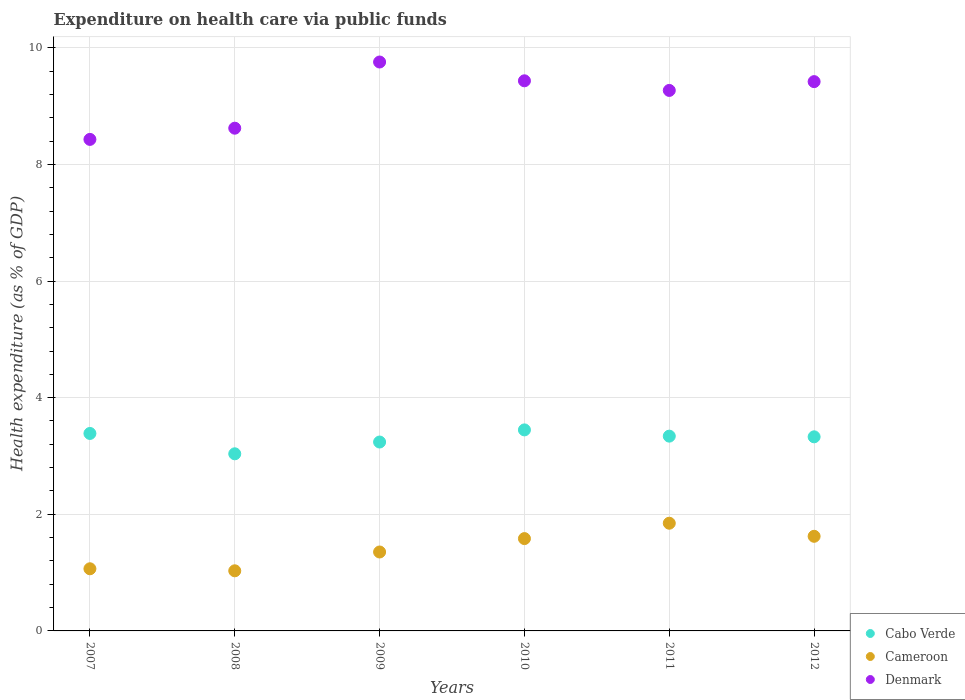Is the number of dotlines equal to the number of legend labels?
Offer a terse response. Yes. What is the expenditure made on health care in Cameroon in 2008?
Give a very brief answer. 1.03. Across all years, what is the maximum expenditure made on health care in Denmark?
Offer a terse response. 9.76. Across all years, what is the minimum expenditure made on health care in Denmark?
Your answer should be compact. 8.43. In which year was the expenditure made on health care in Denmark minimum?
Provide a succinct answer. 2007. What is the total expenditure made on health care in Cameroon in the graph?
Your answer should be very brief. 8.5. What is the difference between the expenditure made on health care in Cabo Verde in 2007 and that in 2009?
Provide a short and direct response. 0.15. What is the difference between the expenditure made on health care in Denmark in 2012 and the expenditure made on health care in Cabo Verde in 2009?
Ensure brevity in your answer.  6.18. What is the average expenditure made on health care in Denmark per year?
Keep it short and to the point. 9.15. In the year 2010, what is the difference between the expenditure made on health care in Cabo Verde and expenditure made on health care in Cameroon?
Offer a very short reply. 1.86. What is the ratio of the expenditure made on health care in Cameroon in 2008 to that in 2011?
Ensure brevity in your answer.  0.56. Is the expenditure made on health care in Cabo Verde in 2010 less than that in 2011?
Offer a terse response. No. Is the difference between the expenditure made on health care in Cabo Verde in 2007 and 2010 greater than the difference between the expenditure made on health care in Cameroon in 2007 and 2010?
Provide a short and direct response. Yes. What is the difference between the highest and the second highest expenditure made on health care in Cabo Verde?
Give a very brief answer. 0.06. What is the difference between the highest and the lowest expenditure made on health care in Denmark?
Keep it short and to the point. 1.33. In how many years, is the expenditure made on health care in Denmark greater than the average expenditure made on health care in Denmark taken over all years?
Give a very brief answer. 4. Does the expenditure made on health care in Cameroon monotonically increase over the years?
Give a very brief answer. No. Is the expenditure made on health care in Denmark strictly greater than the expenditure made on health care in Cameroon over the years?
Ensure brevity in your answer.  Yes. Is the expenditure made on health care in Cabo Verde strictly less than the expenditure made on health care in Denmark over the years?
Offer a very short reply. Yes. What is the difference between two consecutive major ticks on the Y-axis?
Your answer should be very brief. 2. Does the graph contain grids?
Make the answer very short. Yes. What is the title of the graph?
Give a very brief answer. Expenditure on health care via public funds. What is the label or title of the Y-axis?
Keep it short and to the point. Health expenditure (as % of GDP). What is the Health expenditure (as % of GDP) of Cabo Verde in 2007?
Provide a short and direct response. 3.39. What is the Health expenditure (as % of GDP) of Cameroon in 2007?
Give a very brief answer. 1.07. What is the Health expenditure (as % of GDP) in Denmark in 2007?
Ensure brevity in your answer.  8.43. What is the Health expenditure (as % of GDP) in Cabo Verde in 2008?
Your response must be concise. 3.04. What is the Health expenditure (as % of GDP) in Cameroon in 2008?
Your answer should be compact. 1.03. What is the Health expenditure (as % of GDP) in Denmark in 2008?
Offer a terse response. 8.62. What is the Health expenditure (as % of GDP) in Cabo Verde in 2009?
Provide a short and direct response. 3.24. What is the Health expenditure (as % of GDP) in Cameroon in 2009?
Your answer should be compact. 1.35. What is the Health expenditure (as % of GDP) of Denmark in 2009?
Offer a very short reply. 9.76. What is the Health expenditure (as % of GDP) of Cabo Verde in 2010?
Provide a short and direct response. 3.45. What is the Health expenditure (as % of GDP) of Cameroon in 2010?
Give a very brief answer. 1.58. What is the Health expenditure (as % of GDP) of Denmark in 2010?
Offer a very short reply. 9.43. What is the Health expenditure (as % of GDP) of Cabo Verde in 2011?
Keep it short and to the point. 3.34. What is the Health expenditure (as % of GDP) in Cameroon in 2011?
Provide a short and direct response. 1.85. What is the Health expenditure (as % of GDP) of Denmark in 2011?
Your answer should be compact. 9.27. What is the Health expenditure (as % of GDP) in Cabo Verde in 2012?
Keep it short and to the point. 3.33. What is the Health expenditure (as % of GDP) of Cameroon in 2012?
Offer a very short reply. 1.62. What is the Health expenditure (as % of GDP) of Denmark in 2012?
Keep it short and to the point. 9.42. Across all years, what is the maximum Health expenditure (as % of GDP) in Cabo Verde?
Your answer should be compact. 3.45. Across all years, what is the maximum Health expenditure (as % of GDP) of Cameroon?
Offer a terse response. 1.85. Across all years, what is the maximum Health expenditure (as % of GDP) of Denmark?
Ensure brevity in your answer.  9.76. Across all years, what is the minimum Health expenditure (as % of GDP) of Cabo Verde?
Ensure brevity in your answer.  3.04. Across all years, what is the minimum Health expenditure (as % of GDP) in Cameroon?
Your answer should be compact. 1.03. Across all years, what is the minimum Health expenditure (as % of GDP) of Denmark?
Offer a very short reply. 8.43. What is the total Health expenditure (as % of GDP) of Cabo Verde in the graph?
Provide a short and direct response. 19.78. What is the total Health expenditure (as % of GDP) of Cameroon in the graph?
Keep it short and to the point. 8.5. What is the total Health expenditure (as % of GDP) of Denmark in the graph?
Offer a terse response. 54.93. What is the difference between the Health expenditure (as % of GDP) of Cabo Verde in 2007 and that in 2008?
Your answer should be compact. 0.35. What is the difference between the Health expenditure (as % of GDP) in Cameroon in 2007 and that in 2008?
Your answer should be compact. 0.03. What is the difference between the Health expenditure (as % of GDP) in Denmark in 2007 and that in 2008?
Make the answer very short. -0.19. What is the difference between the Health expenditure (as % of GDP) in Cabo Verde in 2007 and that in 2009?
Give a very brief answer. 0.15. What is the difference between the Health expenditure (as % of GDP) of Cameroon in 2007 and that in 2009?
Keep it short and to the point. -0.29. What is the difference between the Health expenditure (as % of GDP) of Denmark in 2007 and that in 2009?
Offer a terse response. -1.33. What is the difference between the Health expenditure (as % of GDP) of Cabo Verde in 2007 and that in 2010?
Give a very brief answer. -0.06. What is the difference between the Health expenditure (as % of GDP) of Cameroon in 2007 and that in 2010?
Provide a short and direct response. -0.52. What is the difference between the Health expenditure (as % of GDP) in Denmark in 2007 and that in 2010?
Provide a short and direct response. -1. What is the difference between the Health expenditure (as % of GDP) in Cabo Verde in 2007 and that in 2011?
Offer a very short reply. 0.05. What is the difference between the Health expenditure (as % of GDP) of Cameroon in 2007 and that in 2011?
Offer a very short reply. -0.78. What is the difference between the Health expenditure (as % of GDP) in Denmark in 2007 and that in 2011?
Offer a terse response. -0.84. What is the difference between the Health expenditure (as % of GDP) of Cabo Verde in 2007 and that in 2012?
Your answer should be compact. 0.06. What is the difference between the Health expenditure (as % of GDP) in Cameroon in 2007 and that in 2012?
Offer a very short reply. -0.56. What is the difference between the Health expenditure (as % of GDP) of Denmark in 2007 and that in 2012?
Your answer should be compact. -0.99. What is the difference between the Health expenditure (as % of GDP) in Cabo Verde in 2008 and that in 2009?
Your response must be concise. -0.2. What is the difference between the Health expenditure (as % of GDP) in Cameroon in 2008 and that in 2009?
Your answer should be very brief. -0.32. What is the difference between the Health expenditure (as % of GDP) of Denmark in 2008 and that in 2009?
Provide a succinct answer. -1.13. What is the difference between the Health expenditure (as % of GDP) of Cabo Verde in 2008 and that in 2010?
Your answer should be compact. -0.41. What is the difference between the Health expenditure (as % of GDP) in Cameroon in 2008 and that in 2010?
Your response must be concise. -0.55. What is the difference between the Health expenditure (as % of GDP) of Denmark in 2008 and that in 2010?
Give a very brief answer. -0.81. What is the difference between the Health expenditure (as % of GDP) in Cabo Verde in 2008 and that in 2011?
Ensure brevity in your answer.  -0.3. What is the difference between the Health expenditure (as % of GDP) in Cameroon in 2008 and that in 2011?
Make the answer very short. -0.82. What is the difference between the Health expenditure (as % of GDP) in Denmark in 2008 and that in 2011?
Keep it short and to the point. -0.65. What is the difference between the Health expenditure (as % of GDP) in Cabo Verde in 2008 and that in 2012?
Keep it short and to the point. -0.29. What is the difference between the Health expenditure (as % of GDP) of Cameroon in 2008 and that in 2012?
Provide a short and direct response. -0.59. What is the difference between the Health expenditure (as % of GDP) of Denmark in 2008 and that in 2012?
Your response must be concise. -0.8. What is the difference between the Health expenditure (as % of GDP) of Cabo Verde in 2009 and that in 2010?
Offer a terse response. -0.21. What is the difference between the Health expenditure (as % of GDP) of Cameroon in 2009 and that in 2010?
Make the answer very short. -0.23. What is the difference between the Health expenditure (as % of GDP) in Denmark in 2009 and that in 2010?
Make the answer very short. 0.32. What is the difference between the Health expenditure (as % of GDP) of Cabo Verde in 2009 and that in 2011?
Keep it short and to the point. -0.1. What is the difference between the Health expenditure (as % of GDP) of Cameroon in 2009 and that in 2011?
Ensure brevity in your answer.  -0.49. What is the difference between the Health expenditure (as % of GDP) of Denmark in 2009 and that in 2011?
Offer a very short reply. 0.49. What is the difference between the Health expenditure (as % of GDP) in Cabo Verde in 2009 and that in 2012?
Make the answer very short. -0.09. What is the difference between the Health expenditure (as % of GDP) in Cameroon in 2009 and that in 2012?
Your answer should be very brief. -0.27. What is the difference between the Health expenditure (as % of GDP) in Denmark in 2009 and that in 2012?
Provide a succinct answer. 0.34. What is the difference between the Health expenditure (as % of GDP) of Cabo Verde in 2010 and that in 2011?
Provide a succinct answer. 0.11. What is the difference between the Health expenditure (as % of GDP) of Cameroon in 2010 and that in 2011?
Provide a succinct answer. -0.26. What is the difference between the Health expenditure (as % of GDP) in Denmark in 2010 and that in 2011?
Give a very brief answer. 0.17. What is the difference between the Health expenditure (as % of GDP) in Cabo Verde in 2010 and that in 2012?
Ensure brevity in your answer.  0.12. What is the difference between the Health expenditure (as % of GDP) of Cameroon in 2010 and that in 2012?
Your response must be concise. -0.04. What is the difference between the Health expenditure (as % of GDP) in Denmark in 2010 and that in 2012?
Give a very brief answer. 0.01. What is the difference between the Health expenditure (as % of GDP) of Cabo Verde in 2011 and that in 2012?
Offer a very short reply. 0.01. What is the difference between the Health expenditure (as % of GDP) in Cameroon in 2011 and that in 2012?
Provide a succinct answer. 0.22. What is the difference between the Health expenditure (as % of GDP) in Denmark in 2011 and that in 2012?
Your response must be concise. -0.15. What is the difference between the Health expenditure (as % of GDP) in Cabo Verde in 2007 and the Health expenditure (as % of GDP) in Cameroon in 2008?
Make the answer very short. 2.36. What is the difference between the Health expenditure (as % of GDP) of Cabo Verde in 2007 and the Health expenditure (as % of GDP) of Denmark in 2008?
Provide a short and direct response. -5.23. What is the difference between the Health expenditure (as % of GDP) of Cameroon in 2007 and the Health expenditure (as % of GDP) of Denmark in 2008?
Ensure brevity in your answer.  -7.56. What is the difference between the Health expenditure (as % of GDP) in Cabo Verde in 2007 and the Health expenditure (as % of GDP) in Cameroon in 2009?
Your answer should be compact. 2.03. What is the difference between the Health expenditure (as % of GDP) of Cabo Verde in 2007 and the Health expenditure (as % of GDP) of Denmark in 2009?
Your answer should be very brief. -6.37. What is the difference between the Health expenditure (as % of GDP) in Cameroon in 2007 and the Health expenditure (as % of GDP) in Denmark in 2009?
Your response must be concise. -8.69. What is the difference between the Health expenditure (as % of GDP) of Cabo Verde in 2007 and the Health expenditure (as % of GDP) of Cameroon in 2010?
Keep it short and to the point. 1.8. What is the difference between the Health expenditure (as % of GDP) of Cabo Verde in 2007 and the Health expenditure (as % of GDP) of Denmark in 2010?
Keep it short and to the point. -6.05. What is the difference between the Health expenditure (as % of GDP) of Cameroon in 2007 and the Health expenditure (as % of GDP) of Denmark in 2010?
Offer a very short reply. -8.37. What is the difference between the Health expenditure (as % of GDP) in Cabo Verde in 2007 and the Health expenditure (as % of GDP) in Cameroon in 2011?
Ensure brevity in your answer.  1.54. What is the difference between the Health expenditure (as % of GDP) in Cabo Verde in 2007 and the Health expenditure (as % of GDP) in Denmark in 2011?
Offer a very short reply. -5.88. What is the difference between the Health expenditure (as % of GDP) of Cameroon in 2007 and the Health expenditure (as % of GDP) of Denmark in 2011?
Offer a very short reply. -8.2. What is the difference between the Health expenditure (as % of GDP) of Cabo Verde in 2007 and the Health expenditure (as % of GDP) of Cameroon in 2012?
Keep it short and to the point. 1.76. What is the difference between the Health expenditure (as % of GDP) of Cabo Verde in 2007 and the Health expenditure (as % of GDP) of Denmark in 2012?
Offer a terse response. -6.03. What is the difference between the Health expenditure (as % of GDP) in Cameroon in 2007 and the Health expenditure (as % of GDP) in Denmark in 2012?
Provide a short and direct response. -8.35. What is the difference between the Health expenditure (as % of GDP) in Cabo Verde in 2008 and the Health expenditure (as % of GDP) in Cameroon in 2009?
Offer a terse response. 1.68. What is the difference between the Health expenditure (as % of GDP) in Cabo Verde in 2008 and the Health expenditure (as % of GDP) in Denmark in 2009?
Give a very brief answer. -6.72. What is the difference between the Health expenditure (as % of GDP) in Cameroon in 2008 and the Health expenditure (as % of GDP) in Denmark in 2009?
Your answer should be very brief. -8.73. What is the difference between the Health expenditure (as % of GDP) of Cabo Verde in 2008 and the Health expenditure (as % of GDP) of Cameroon in 2010?
Give a very brief answer. 1.45. What is the difference between the Health expenditure (as % of GDP) of Cabo Verde in 2008 and the Health expenditure (as % of GDP) of Denmark in 2010?
Provide a short and direct response. -6.4. What is the difference between the Health expenditure (as % of GDP) in Cameroon in 2008 and the Health expenditure (as % of GDP) in Denmark in 2010?
Your answer should be very brief. -8.4. What is the difference between the Health expenditure (as % of GDP) of Cabo Verde in 2008 and the Health expenditure (as % of GDP) of Cameroon in 2011?
Provide a succinct answer. 1.19. What is the difference between the Health expenditure (as % of GDP) of Cabo Verde in 2008 and the Health expenditure (as % of GDP) of Denmark in 2011?
Make the answer very short. -6.23. What is the difference between the Health expenditure (as % of GDP) of Cameroon in 2008 and the Health expenditure (as % of GDP) of Denmark in 2011?
Give a very brief answer. -8.24. What is the difference between the Health expenditure (as % of GDP) of Cabo Verde in 2008 and the Health expenditure (as % of GDP) of Cameroon in 2012?
Provide a short and direct response. 1.41. What is the difference between the Health expenditure (as % of GDP) in Cabo Verde in 2008 and the Health expenditure (as % of GDP) in Denmark in 2012?
Provide a short and direct response. -6.38. What is the difference between the Health expenditure (as % of GDP) of Cameroon in 2008 and the Health expenditure (as % of GDP) of Denmark in 2012?
Your response must be concise. -8.39. What is the difference between the Health expenditure (as % of GDP) in Cabo Verde in 2009 and the Health expenditure (as % of GDP) in Cameroon in 2010?
Provide a succinct answer. 1.66. What is the difference between the Health expenditure (as % of GDP) of Cabo Verde in 2009 and the Health expenditure (as % of GDP) of Denmark in 2010?
Provide a succinct answer. -6.19. What is the difference between the Health expenditure (as % of GDP) of Cameroon in 2009 and the Health expenditure (as % of GDP) of Denmark in 2010?
Offer a terse response. -8.08. What is the difference between the Health expenditure (as % of GDP) in Cabo Verde in 2009 and the Health expenditure (as % of GDP) in Cameroon in 2011?
Provide a succinct answer. 1.39. What is the difference between the Health expenditure (as % of GDP) in Cabo Verde in 2009 and the Health expenditure (as % of GDP) in Denmark in 2011?
Keep it short and to the point. -6.03. What is the difference between the Health expenditure (as % of GDP) in Cameroon in 2009 and the Health expenditure (as % of GDP) in Denmark in 2011?
Ensure brevity in your answer.  -7.92. What is the difference between the Health expenditure (as % of GDP) of Cabo Verde in 2009 and the Health expenditure (as % of GDP) of Cameroon in 2012?
Make the answer very short. 1.62. What is the difference between the Health expenditure (as % of GDP) of Cabo Verde in 2009 and the Health expenditure (as % of GDP) of Denmark in 2012?
Your answer should be compact. -6.18. What is the difference between the Health expenditure (as % of GDP) in Cameroon in 2009 and the Health expenditure (as % of GDP) in Denmark in 2012?
Keep it short and to the point. -8.07. What is the difference between the Health expenditure (as % of GDP) of Cabo Verde in 2010 and the Health expenditure (as % of GDP) of Cameroon in 2011?
Offer a very short reply. 1.6. What is the difference between the Health expenditure (as % of GDP) in Cabo Verde in 2010 and the Health expenditure (as % of GDP) in Denmark in 2011?
Give a very brief answer. -5.82. What is the difference between the Health expenditure (as % of GDP) of Cameroon in 2010 and the Health expenditure (as % of GDP) of Denmark in 2011?
Keep it short and to the point. -7.69. What is the difference between the Health expenditure (as % of GDP) in Cabo Verde in 2010 and the Health expenditure (as % of GDP) in Cameroon in 2012?
Your response must be concise. 1.82. What is the difference between the Health expenditure (as % of GDP) in Cabo Verde in 2010 and the Health expenditure (as % of GDP) in Denmark in 2012?
Your response must be concise. -5.97. What is the difference between the Health expenditure (as % of GDP) in Cameroon in 2010 and the Health expenditure (as % of GDP) in Denmark in 2012?
Ensure brevity in your answer.  -7.84. What is the difference between the Health expenditure (as % of GDP) of Cabo Verde in 2011 and the Health expenditure (as % of GDP) of Cameroon in 2012?
Offer a terse response. 1.72. What is the difference between the Health expenditure (as % of GDP) of Cabo Verde in 2011 and the Health expenditure (as % of GDP) of Denmark in 2012?
Your answer should be very brief. -6.08. What is the difference between the Health expenditure (as % of GDP) in Cameroon in 2011 and the Health expenditure (as % of GDP) in Denmark in 2012?
Ensure brevity in your answer.  -7.57. What is the average Health expenditure (as % of GDP) in Cabo Verde per year?
Make the answer very short. 3.3. What is the average Health expenditure (as % of GDP) of Cameroon per year?
Keep it short and to the point. 1.42. What is the average Health expenditure (as % of GDP) in Denmark per year?
Offer a terse response. 9.15. In the year 2007, what is the difference between the Health expenditure (as % of GDP) of Cabo Verde and Health expenditure (as % of GDP) of Cameroon?
Provide a succinct answer. 2.32. In the year 2007, what is the difference between the Health expenditure (as % of GDP) in Cabo Verde and Health expenditure (as % of GDP) in Denmark?
Keep it short and to the point. -5.04. In the year 2007, what is the difference between the Health expenditure (as % of GDP) in Cameroon and Health expenditure (as % of GDP) in Denmark?
Your answer should be compact. -7.36. In the year 2008, what is the difference between the Health expenditure (as % of GDP) of Cabo Verde and Health expenditure (as % of GDP) of Cameroon?
Provide a succinct answer. 2.01. In the year 2008, what is the difference between the Health expenditure (as % of GDP) in Cabo Verde and Health expenditure (as % of GDP) in Denmark?
Your answer should be very brief. -5.58. In the year 2008, what is the difference between the Health expenditure (as % of GDP) in Cameroon and Health expenditure (as % of GDP) in Denmark?
Provide a short and direct response. -7.59. In the year 2009, what is the difference between the Health expenditure (as % of GDP) in Cabo Verde and Health expenditure (as % of GDP) in Cameroon?
Provide a succinct answer. 1.89. In the year 2009, what is the difference between the Health expenditure (as % of GDP) of Cabo Verde and Health expenditure (as % of GDP) of Denmark?
Your response must be concise. -6.52. In the year 2009, what is the difference between the Health expenditure (as % of GDP) in Cameroon and Health expenditure (as % of GDP) in Denmark?
Your answer should be very brief. -8.4. In the year 2010, what is the difference between the Health expenditure (as % of GDP) in Cabo Verde and Health expenditure (as % of GDP) in Cameroon?
Offer a terse response. 1.86. In the year 2010, what is the difference between the Health expenditure (as % of GDP) of Cabo Verde and Health expenditure (as % of GDP) of Denmark?
Ensure brevity in your answer.  -5.99. In the year 2010, what is the difference between the Health expenditure (as % of GDP) in Cameroon and Health expenditure (as % of GDP) in Denmark?
Provide a short and direct response. -7.85. In the year 2011, what is the difference between the Health expenditure (as % of GDP) of Cabo Verde and Health expenditure (as % of GDP) of Cameroon?
Your response must be concise. 1.49. In the year 2011, what is the difference between the Health expenditure (as % of GDP) in Cabo Verde and Health expenditure (as % of GDP) in Denmark?
Offer a terse response. -5.93. In the year 2011, what is the difference between the Health expenditure (as % of GDP) in Cameroon and Health expenditure (as % of GDP) in Denmark?
Make the answer very short. -7.42. In the year 2012, what is the difference between the Health expenditure (as % of GDP) of Cabo Verde and Health expenditure (as % of GDP) of Cameroon?
Ensure brevity in your answer.  1.71. In the year 2012, what is the difference between the Health expenditure (as % of GDP) of Cabo Verde and Health expenditure (as % of GDP) of Denmark?
Offer a very short reply. -6.09. In the year 2012, what is the difference between the Health expenditure (as % of GDP) in Cameroon and Health expenditure (as % of GDP) in Denmark?
Keep it short and to the point. -7.8. What is the ratio of the Health expenditure (as % of GDP) in Cabo Verde in 2007 to that in 2008?
Provide a short and direct response. 1.11. What is the ratio of the Health expenditure (as % of GDP) in Cameroon in 2007 to that in 2008?
Your answer should be compact. 1.03. What is the ratio of the Health expenditure (as % of GDP) in Denmark in 2007 to that in 2008?
Provide a succinct answer. 0.98. What is the ratio of the Health expenditure (as % of GDP) in Cabo Verde in 2007 to that in 2009?
Your answer should be very brief. 1.05. What is the ratio of the Health expenditure (as % of GDP) in Cameroon in 2007 to that in 2009?
Provide a succinct answer. 0.79. What is the ratio of the Health expenditure (as % of GDP) of Denmark in 2007 to that in 2009?
Your response must be concise. 0.86. What is the ratio of the Health expenditure (as % of GDP) of Cabo Verde in 2007 to that in 2010?
Ensure brevity in your answer.  0.98. What is the ratio of the Health expenditure (as % of GDP) in Cameroon in 2007 to that in 2010?
Provide a succinct answer. 0.67. What is the ratio of the Health expenditure (as % of GDP) of Denmark in 2007 to that in 2010?
Give a very brief answer. 0.89. What is the ratio of the Health expenditure (as % of GDP) of Cabo Verde in 2007 to that in 2011?
Offer a terse response. 1.01. What is the ratio of the Health expenditure (as % of GDP) of Cameroon in 2007 to that in 2011?
Give a very brief answer. 0.58. What is the ratio of the Health expenditure (as % of GDP) of Denmark in 2007 to that in 2011?
Ensure brevity in your answer.  0.91. What is the ratio of the Health expenditure (as % of GDP) of Cabo Verde in 2007 to that in 2012?
Your answer should be compact. 1.02. What is the ratio of the Health expenditure (as % of GDP) in Cameroon in 2007 to that in 2012?
Your answer should be compact. 0.66. What is the ratio of the Health expenditure (as % of GDP) of Denmark in 2007 to that in 2012?
Offer a terse response. 0.89. What is the ratio of the Health expenditure (as % of GDP) of Cabo Verde in 2008 to that in 2009?
Offer a terse response. 0.94. What is the ratio of the Health expenditure (as % of GDP) in Cameroon in 2008 to that in 2009?
Offer a terse response. 0.76. What is the ratio of the Health expenditure (as % of GDP) of Denmark in 2008 to that in 2009?
Ensure brevity in your answer.  0.88. What is the ratio of the Health expenditure (as % of GDP) in Cabo Verde in 2008 to that in 2010?
Give a very brief answer. 0.88. What is the ratio of the Health expenditure (as % of GDP) in Cameroon in 2008 to that in 2010?
Offer a very short reply. 0.65. What is the ratio of the Health expenditure (as % of GDP) of Denmark in 2008 to that in 2010?
Offer a very short reply. 0.91. What is the ratio of the Health expenditure (as % of GDP) in Cabo Verde in 2008 to that in 2011?
Give a very brief answer. 0.91. What is the ratio of the Health expenditure (as % of GDP) in Cameroon in 2008 to that in 2011?
Offer a very short reply. 0.56. What is the ratio of the Health expenditure (as % of GDP) of Denmark in 2008 to that in 2011?
Keep it short and to the point. 0.93. What is the ratio of the Health expenditure (as % of GDP) in Cabo Verde in 2008 to that in 2012?
Keep it short and to the point. 0.91. What is the ratio of the Health expenditure (as % of GDP) in Cameroon in 2008 to that in 2012?
Provide a succinct answer. 0.64. What is the ratio of the Health expenditure (as % of GDP) of Denmark in 2008 to that in 2012?
Provide a succinct answer. 0.92. What is the ratio of the Health expenditure (as % of GDP) of Cabo Verde in 2009 to that in 2010?
Provide a succinct answer. 0.94. What is the ratio of the Health expenditure (as % of GDP) of Cameroon in 2009 to that in 2010?
Offer a terse response. 0.85. What is the ratio of the Health expenditure (as % of GDP) of Denmark in 2009 to that in 2010?
Provide a short and direct response. 1.03. What is the ratio of the Health expenditure (as % of GDP) in Cabo Verde in 2009 to that in 2011?
Your response must be concise. 0.97. What is the ratio of the Health expenditure (as % of GDP) in Cameroon in 2009 to that in 2011?
Your response must be concise. 0.73. What is the ratio of the Health expenditure (as % of GDP) in Denmark in 2009 to that in 2011?
Offer a terse response. 1.05. What is the ratio of the Health expenditure (as % of GDP) of Cabo Verde in 2009 to that in 2012?
Keep it short and to the point. 0.97. What is the ratio of the Health expenditure (as % of GDP) of Cameroon in 2009 to that in 2012?
Give a very brief answer. 0.83. What is the ratio of the Health expenditure (as % of GDP) in Denmark in 2009 to that in 2012?
Offer a very short reply. 1.04. What is the ratio of the Health expenditure (as % of GDP) of Cabo Verde in 2010 to that in 2011?
Ensure brevity in your answer.  1.03. What is the ratio of the Health expenditure (as % of GDP) in Cameroon in 2010 to that in 2011?
Offer a terse response. 0.86. What is the ratio of the Health expenditure (as % of GDP) of Denmark in 2010 to that in 2011?
Your response must be concise. 1.02. What is the ratio of the Health expenditure (as % of GDP) of Cabo Verde in 2010 to that in 2012?
Provide a short and direct response. 1.04. What is the ratio of the Health expenditure (as % of GDP) of Cameroon in 2010 to that in 2012?
Your response must be concise. 0.98. What is the ratio of the Health expenditure (as % of GDP) of Denmark in 2010 to that in 2012?
Offer a terse response. 1. What is the ratio of the Health expenditure (as % of GDP) of Cameroon in 2011 to that in 2012?
Provide a short and direct response. 1.14. What is the difference between the highest and the second highest Health expenditure (as % of GDP) in Cabo Verde?
Give a very brief answer. 0.06. What is the difference between the highest and the second highest Health expenditure (as % of GDP) in Cameroon?
Make the answer very short. 0.22. What is the difference between the highest and the second highest Health expenditure (as % of GDP) of Denmark?
Offer a very short reply. 0.32. What is the difference between the highest and the lowest Health expenditure (as % of GDP) in Cabo Verde?
Your response must be concise. 0.41. What is the difference between the highest and the lowest Health expenditure (as % of GDP) of Cameroon?
Keep it short and to the point. 0.82. What is the difference between the highest and the lowest Health expenditure (as % of GDP) in Denmark?
Provide a short and direct response. 1.33. 